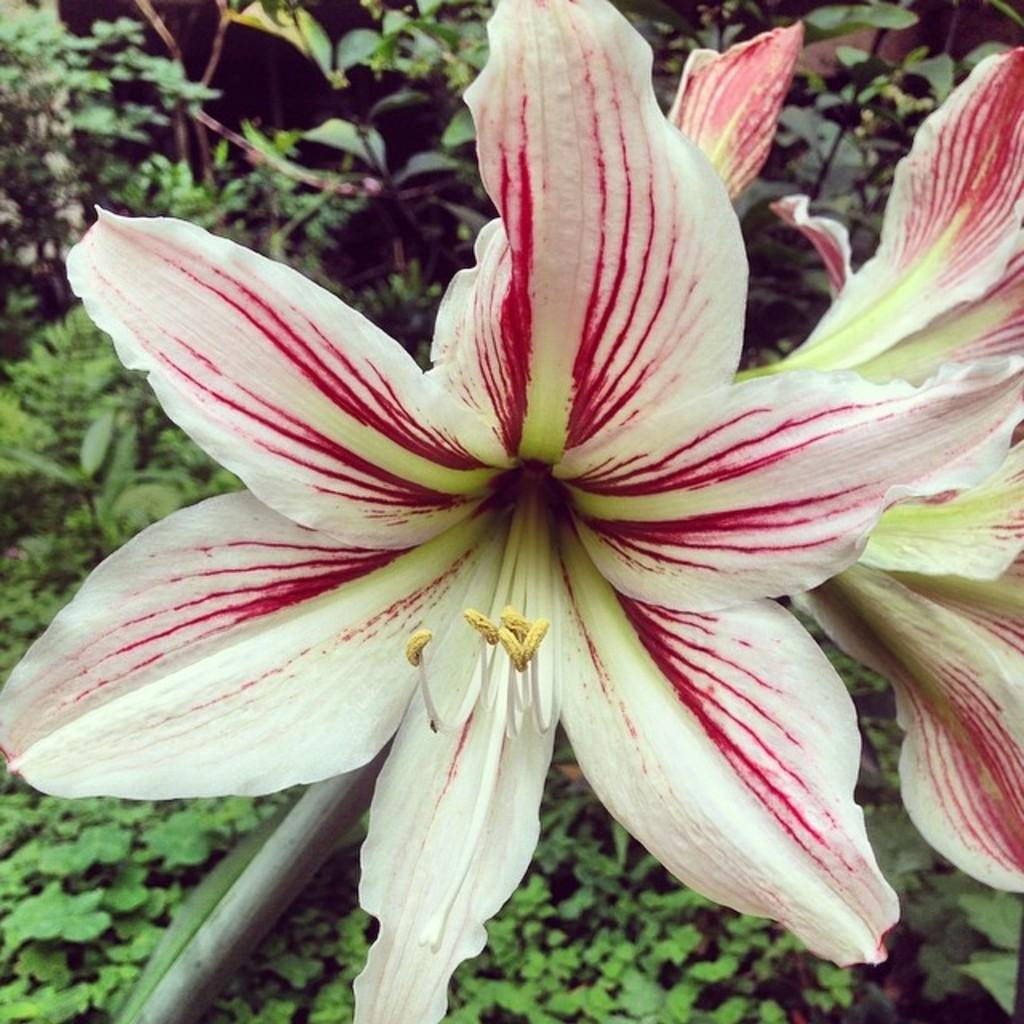What colors are the flowers in the image? The flowers in the image are white and red. Can you describe the plants visible in the background of the image? There are plants in the background of the image. What type of cherry is being used as a decoration in the image? There is no cherry present in the image; it features flowers and plants. Can you see a crow flying in the image? There is no crow visible in the image. 